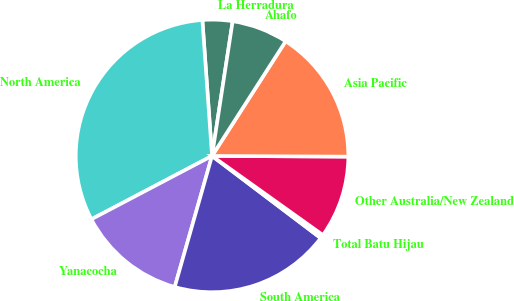Convert chart. <chart><loc_0><loc_0><loc_500><loc_500><pie_chart><fcel>La Herradura<fcel>North America<fcel>Yanacocha<fcel>South America<fcel>Total Batu Hijau<fcel>Other Australia/New Zealand<fcel>Asia Pacific<fcel>Ahafo<nl><fcel>3.55%<fcel>31.57%<fcel>12.89%<fcel>19.11%<fcel>0.44%<fcel>9.78%<fcel>16.0%<fcel>6.66%<nl></chart> 